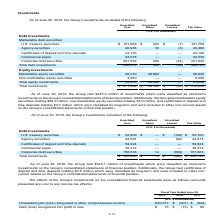According to Atlassian Plc's financial document, As of June 30, 2018, what is the value of the certificates of deposit and time deposits? According to the financial document, $3.6 million. The relevant text states: "certificates of deposit and time deposits totaling $3.6 million which were classified as long-term and were included in other non- current assets on the Group’s con..." Also, As of June 30, 2018, what is the value of short-term investments on the Group's consolidated statements of financial position? According to the financial document, $323.1 million. The relevant text states: "As of June 30, 2018, the Group had $323.1 million of investments which were classified as short-term..." Also, What is the amount of total investments based on fair value? According to the financial document, $326,794 (in thousands). The relevant text states: "Total investments $ 327,640 $ 14 $ (860) $ 326,794..." Also, can you calculate: Based on fair value, what is the difference in value between U.S. treasury securities and agency securities? Based on the calculation: 52,700-22,015, the result is 30685 (in thousands). This is based on the information: "U.S. treasury securities $ 52,809 $ — $ (109) $ 52,700 Agency securities 22,097 — (82) 22,015..." The key data points involved are: 22,015, 52,700. Also, can you calculate: Based on amortized cost, what is the percentage constitution of Agency securities among the total investments? Based on the calculation: 22,097/327,640, the result is 6.74 (percentage). This is based on the information: "Agency securities 22,097 — (82) 22,015 Total investments $ 327,640 $ 14 $ (860) $ 326,794..." The key data points involved are: 22,097, 327,640. Also, can you calculate: Based on fair value, what is the percentage constitution of corporate debt securities among the total investments? Based on the calculation: 157,883/326,794, the result is 48.31 (percentage). This is based on the information: "Corporate debt securities 158,538 14 (669) 157,883 Total investments $ 327,640 $ 14 $ (860) $ 326,794..." The key data points involved are: 157,883, 326,794. 